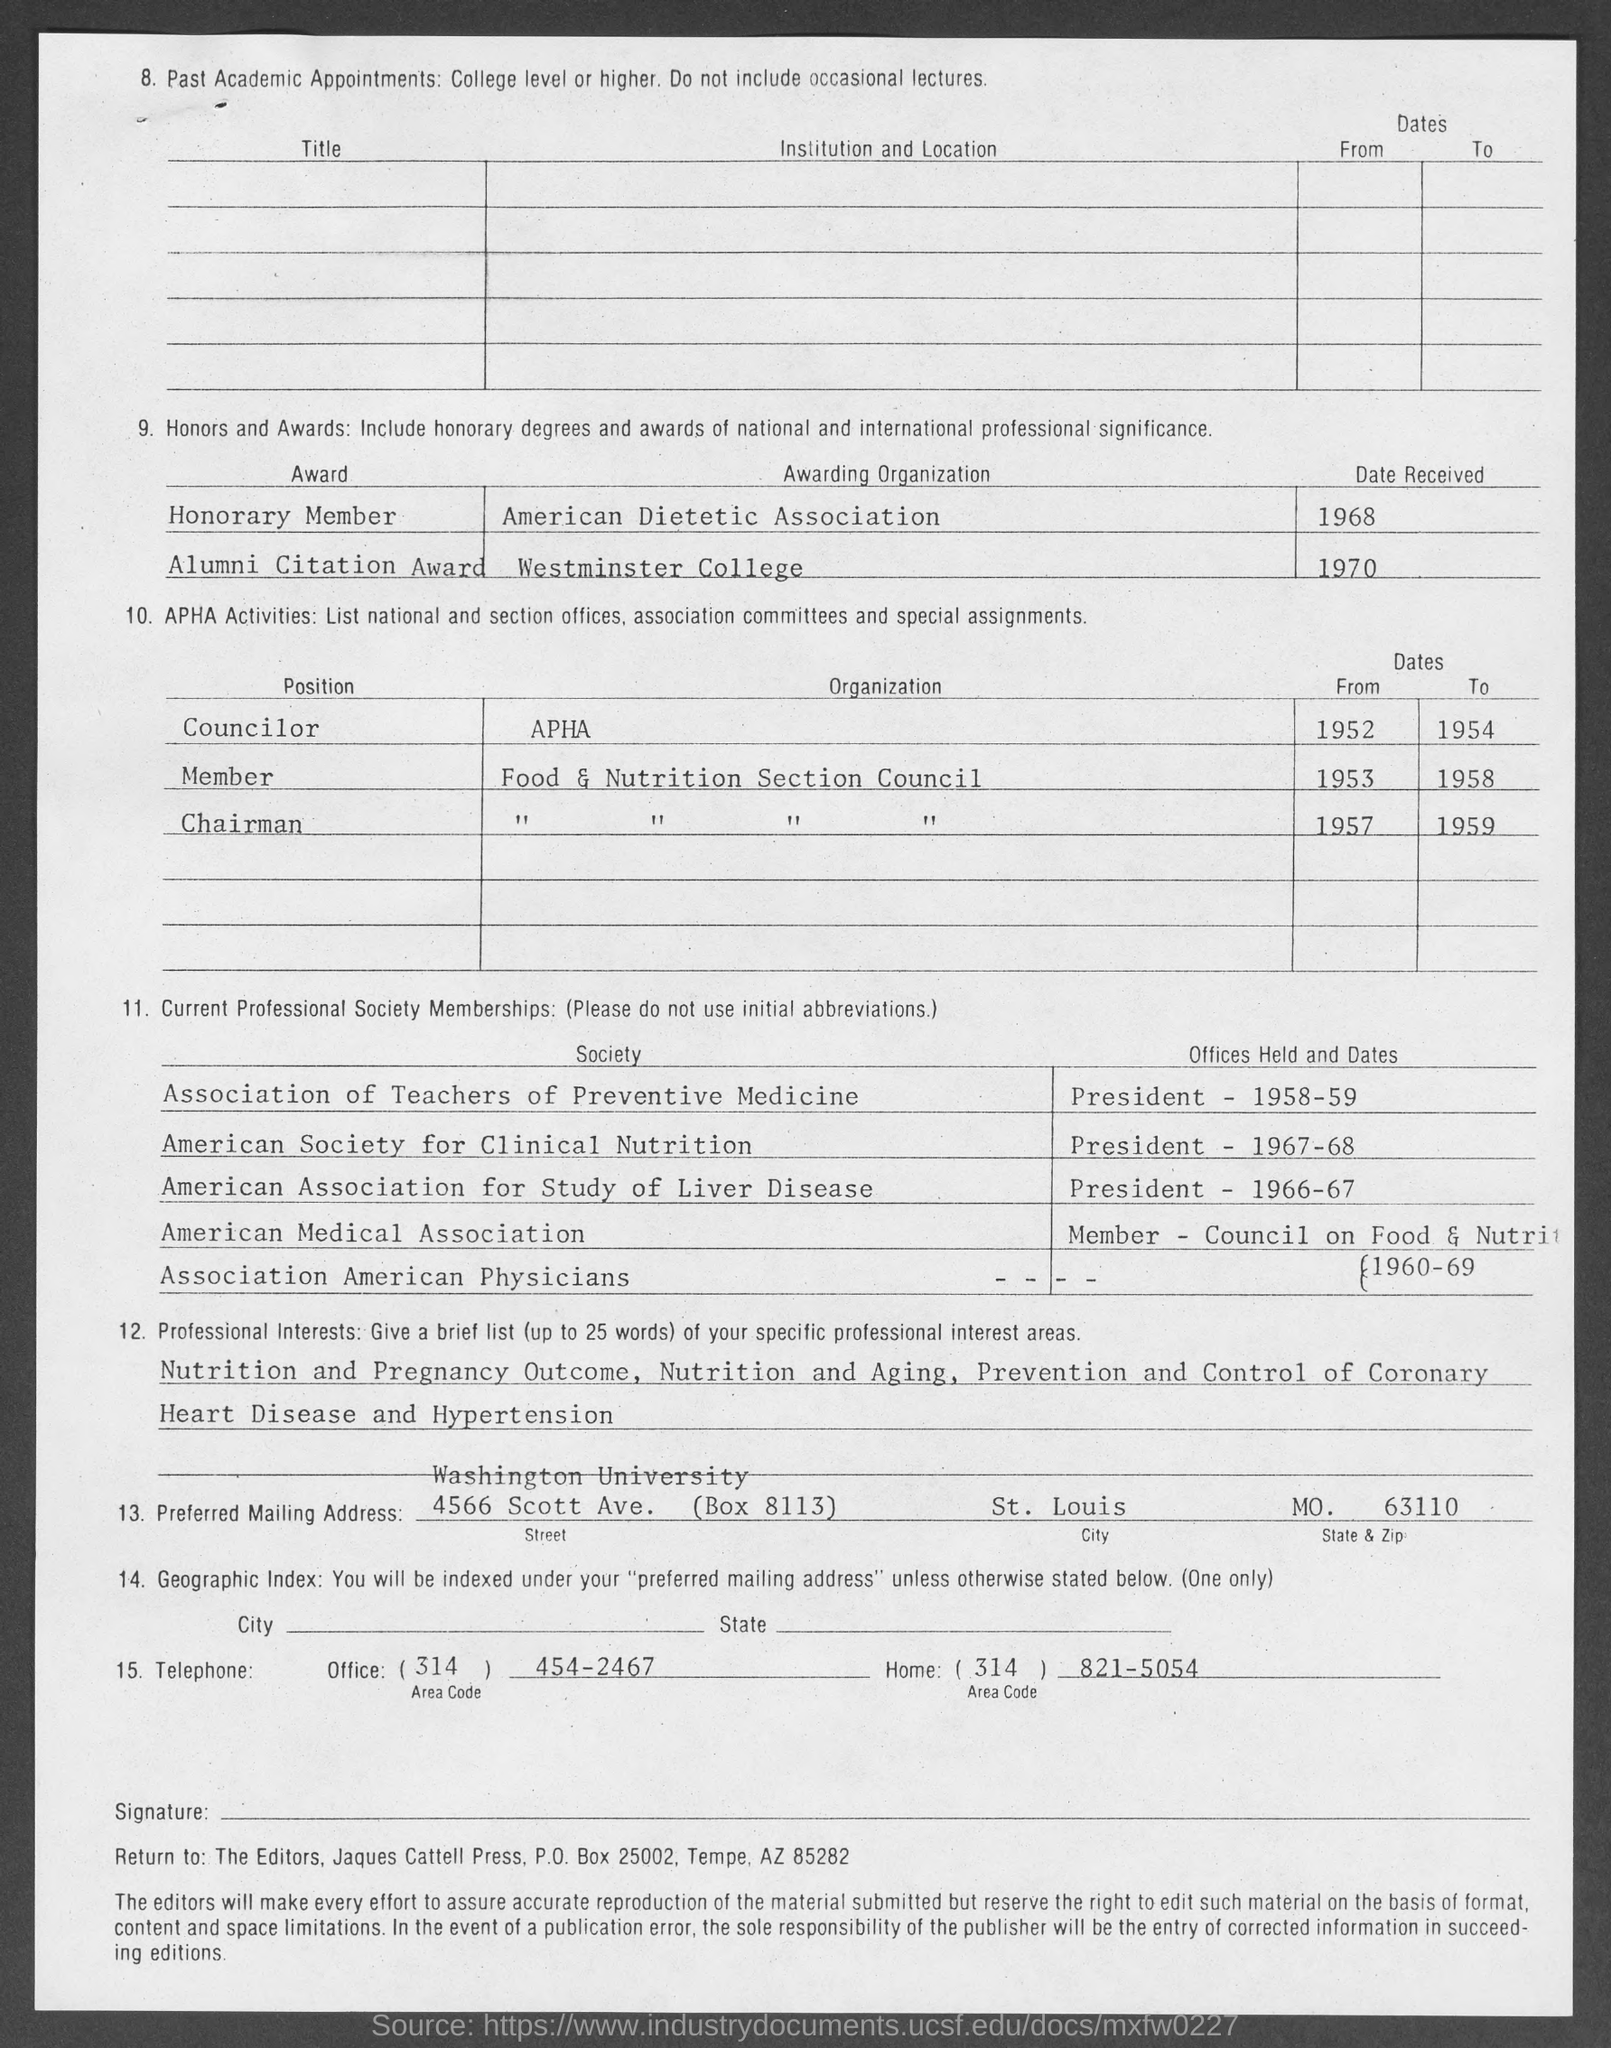Indicate a few pertinent items in this graphic. The position for Apha organization mentioned on the given page is called 'councilor.' The honorary member award was received on the date of 1968. The Alumni Citation Award was received on which date? I believe it was in 1970. The state and zip code mentioned on the given page are MO-63110. The organization that awards the Alumni Citation Award is Westminster College. 